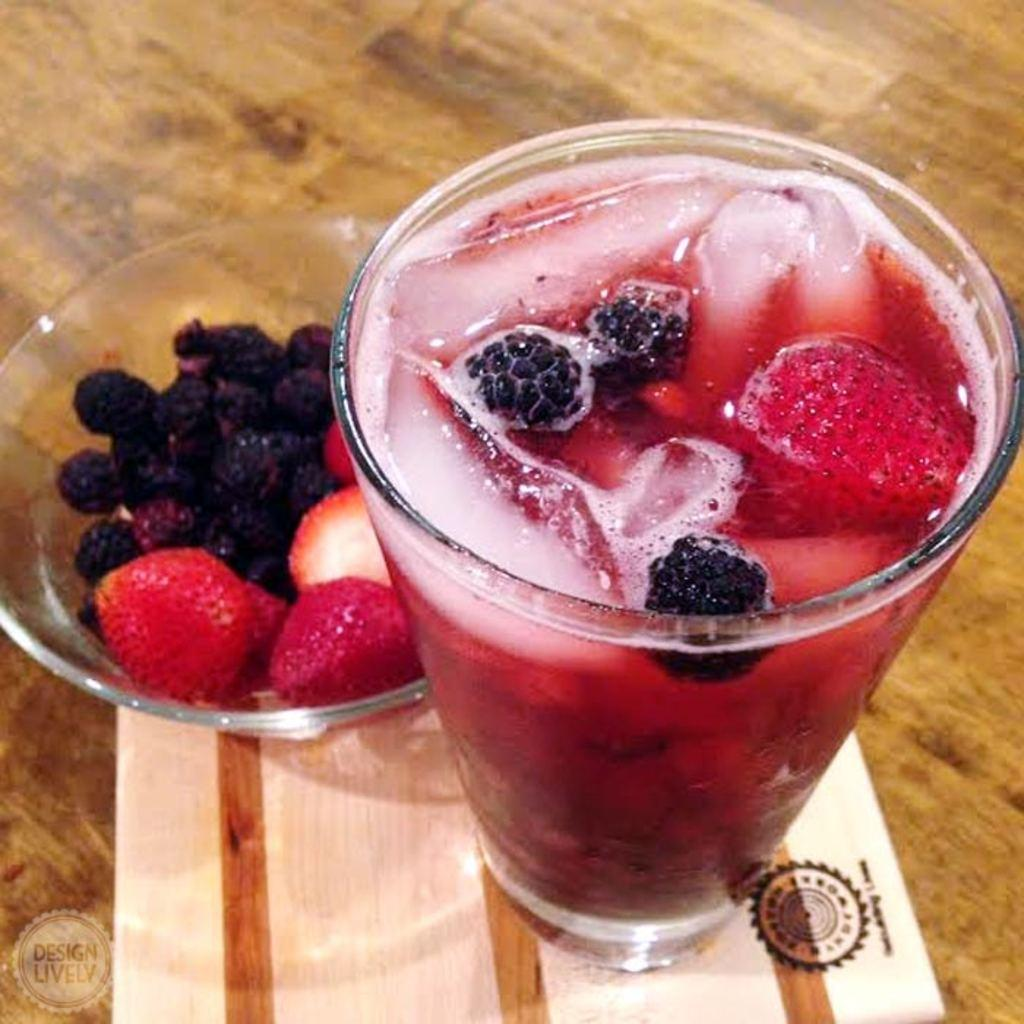What is contained in the glass that is visible in the image? There is juice in the glass. What else can be seen in the image besides the glass? There is a bowl with fruits in the image. What is the color of the table in the image? The table is brown in color. How does the earth contribute to the growth of the fruits in the image? The image does not show the process of fruit growth or the role of the earth in it; it only displays a bowl of fruits. 